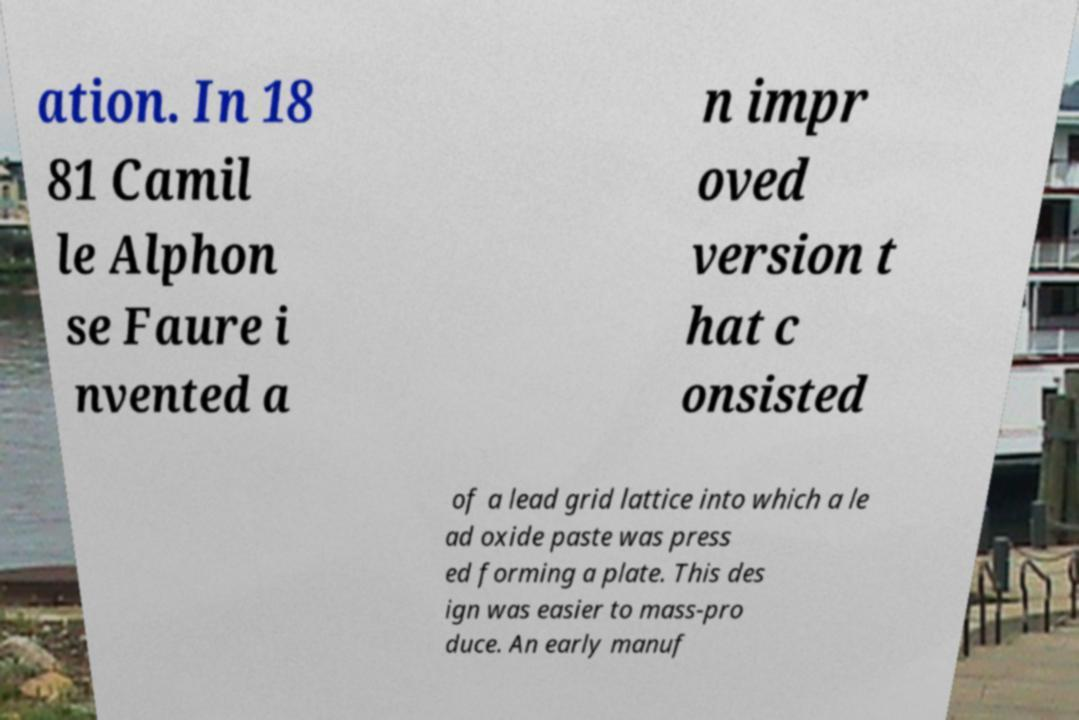Please identify and transcribe the text found in this image. ation. In 18 81 Camil le Alphon se Faure i nvented a n impr oved version t hat c onsisted of a lead grid lattice into which a le ad oxide paste was press ed forming a plate. This des ign was easier to mass-pro duce. An early manuf 